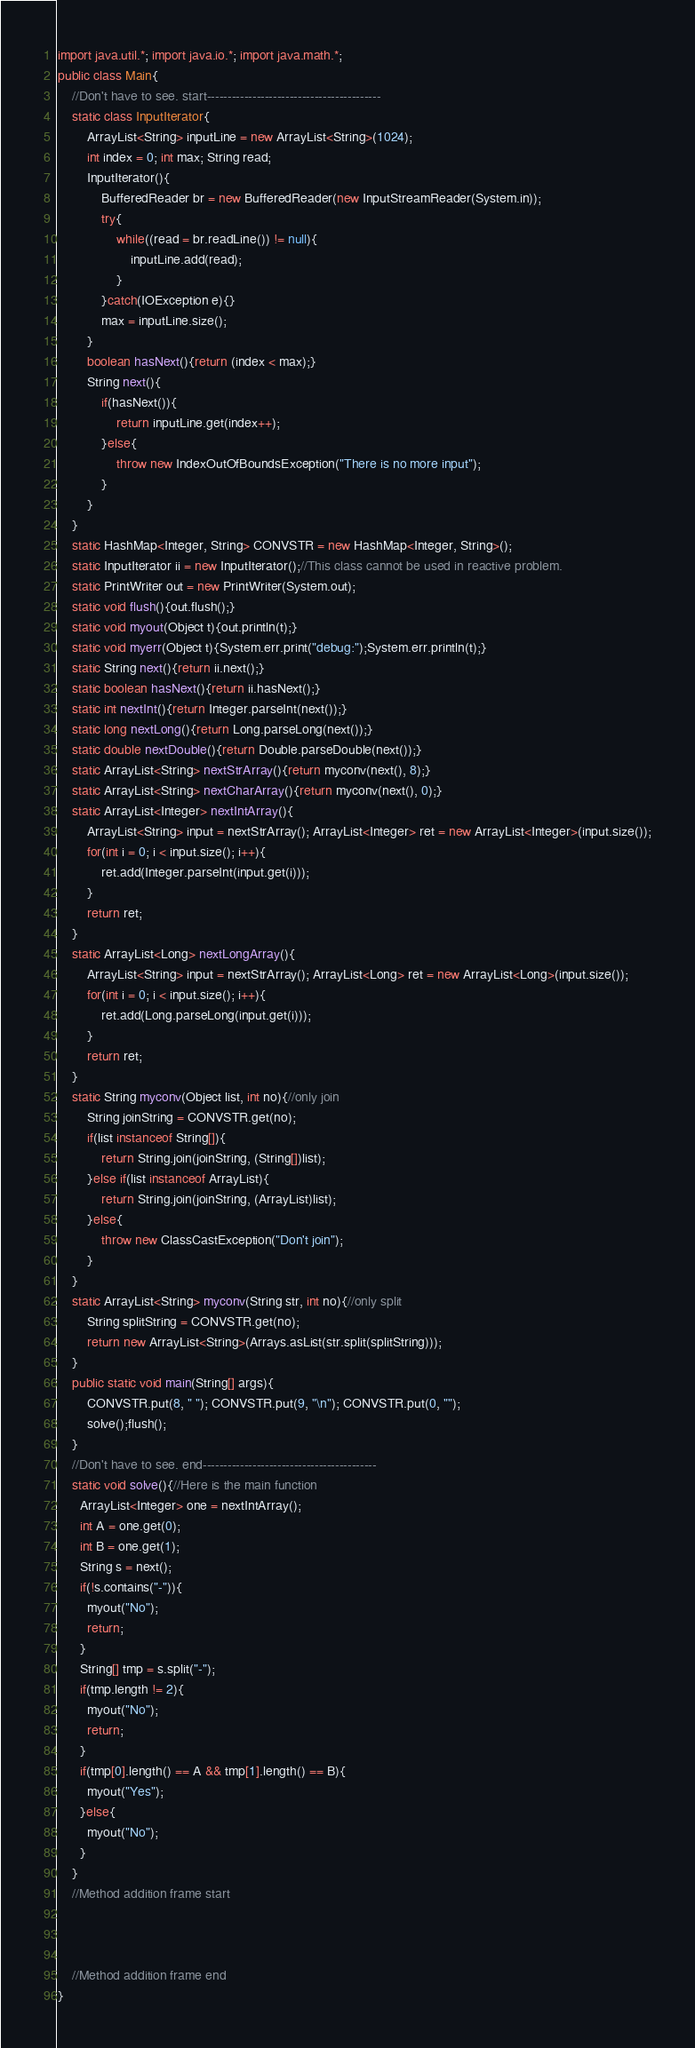<code> <loc_0><loc_0><loc_500><loc_500><_Java_>import java.util.*; import java.io.*; import java.math.*;
public class Main{
	//Don't have to see. start------------------------------------------
	static class InputIterator{
		ArrayList<String> inputLine = new ArrayList<String>(1024);
		int index = 0; int max; String read;
		InputIterator(){
			BufferedReader br = new BufferedReader(new InputStreamReader(System.in));
			try{
				while((read = br.readLine()) != null){
					inputLine.add(read);
				}
			}catch(IOException e){}
			max = inputLine.size();
		}
		boolean hasNext(){return (index < max);}
		String next(){
			if(hasNext()){
				return inputLine.get(index++);
			}else{
				throw new IndexOutOfBoundsException("There is no more input");
			}
		}
	}
	static HashMap<Integer, String> CONVSTR = new HashMap<Integer, String>();
	static InputIterator ii = new InputIterator();//This class cannot be used in reactive problem.
	static PrintWriter out = new PrintWriter(System.out);
	static void flush(){out.flush();}
	static void myout(Object t){out.println(t);}
	static void myerr(Object t){System.err.print("debug:");System.err.println(t);}
	static String next(){return ii.next();}
	static boolean hasNext(){return ii.hasNext();}
	static int nextInt(){return Integer.parseInt(next());}
	static long nextLong(){return Long.parseLong(next());}
	static double nextDouble(){return Double.parseDouble(next());}
	static ArrayList<String> nextStrArray(){return myconv(next(), 8);}
	static ArrayList<String> nextCharArray(){return myconv(next(), 0);}
	static ArrayList<Integer> nextIntArray(){
		ArrayList<String> input = nextStrArray(); ArrayList<Integer> ret = new ArrayList<Integer>(input.size());
		for(int i = 0; i < input.size(); i++){
			ret.add(Integer.parseInt(input.get(i)));
		}
		return ret;
	}
	static ArrayList<Long> nextLongArray(){
		ArrayList<String> input = nextStrArray(); ArrayList<Long> ret = new ArrayList<Long>(input.size());
		for(int i = 0; i < input.size(); i++){
			ret.add(Long.parseLong(input.get(i)));
		}
		return ret;
	}
	static String myconv(Object list, int no){//only join
		String joinString = CONVSTR.get(no);
		if(list instanceof String[]){
			return String.join(joinString, (String[])list);
		}else if(list instanceof ArrayList){
			return String.join(joinString, (ArrayList)list);
		}else{
			throw new ClassCastException("Don't join");
		}
	}
	static ArrayList<String> myconv(String str, int no){//only split
		String splitString = CONVSTR.get(no);
		return new ArrayList<String>(Arrays.asList(str.split(splitString)));
	}
	public static void main(String[] args){
		CONVSTR.put(8, " "); CONVSTR.put(9, "\n"); CONVSTR.put(0, "");
		solve();flush();
	}
	//Don't have to see. end------------------------------------------
	static void solve(){//Here is the main function
      ArrayList<Integer> one = nextIntArray();
      int A = one.get(0);
      int B = one.get(1);
      String s = next();
      if(!s.contains("-")){
        myout("No");
        return;
      }
      String[] tmp = s.split("-");
      if(tmp.length != 2){
        myout("No");
        return;
      }
      if(tmp[0].length() == A && tmp[1].length() == B){
        myout("Yes");
      }else{
        myout("No");
      }
	}
	//Method addition frame start



	//Method addition frame end
}
</code> 